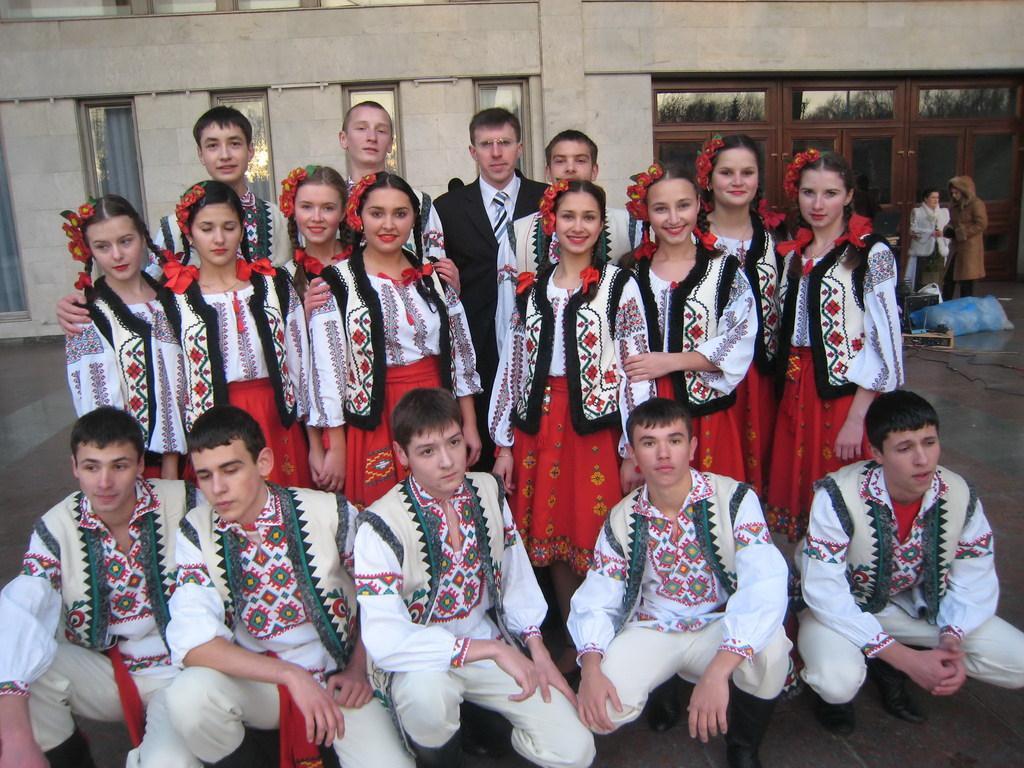Describe this image in one or two sentences. In the picture there are many people standing and laughing, some are sitting in the squat position, behind them there is a building. 